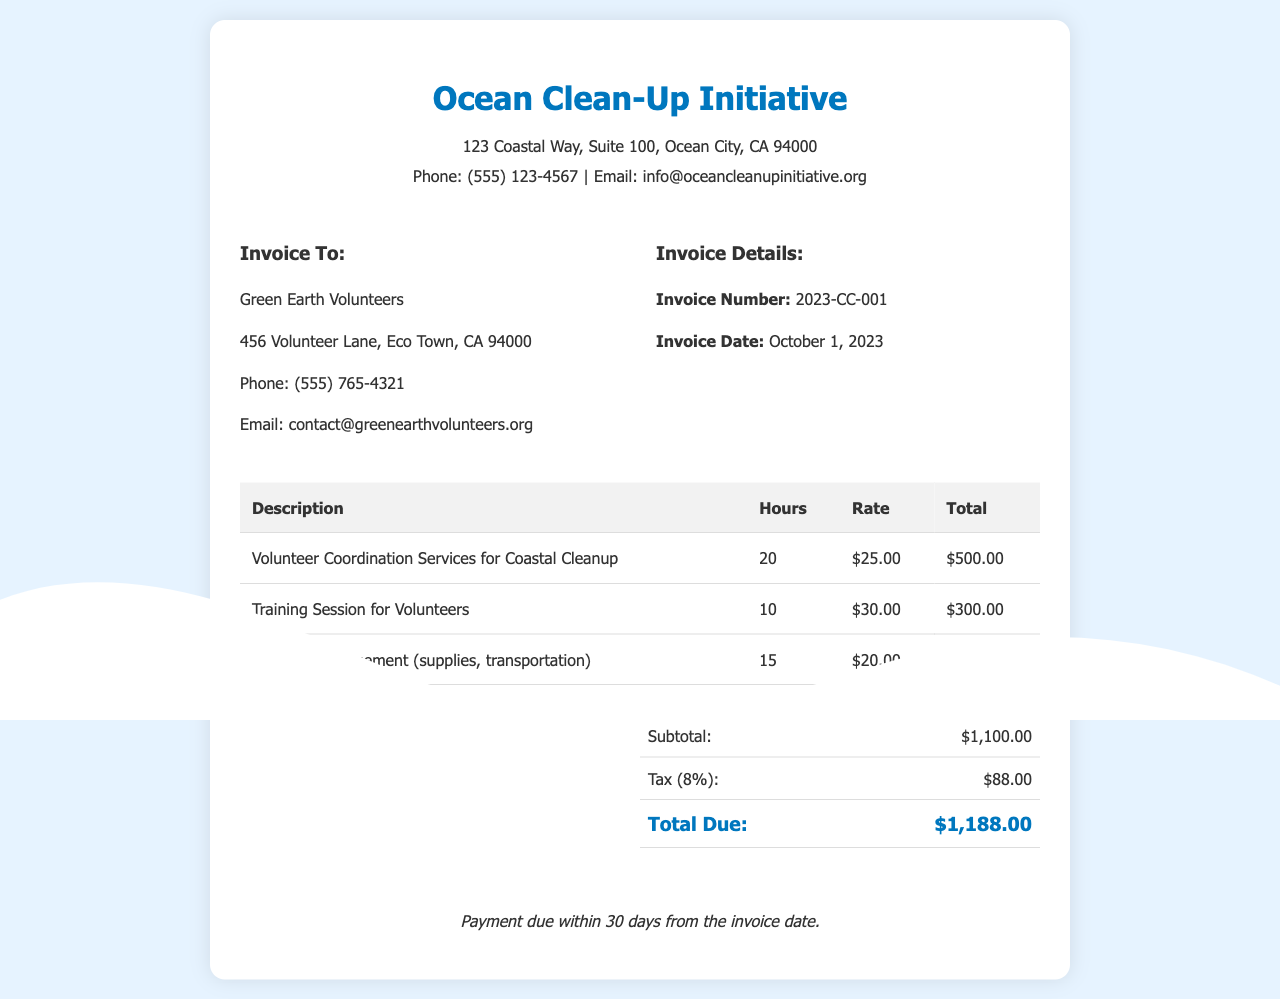What is the invoice number? The invoice number is identified in the invoice details section, which is 2023-CC-001.
Answer: 2023-CC-001 What is the total amount due? The total due is calculated at the bottom of the summary table, which is $1,188.00.
Answer: $1,188.00 Who is the recipient of the invoice? The recipient is listed under the 'Invoice To:' section, which is Green Earth Volunteers.
Answer: Green Earth Volunteers How many hours were worked for volunteer coordination services? The hours for volunteer coordination services are listed as 20 in the table under the relevant description.
Answer: 20 What date was the invoice issued? The invoice date is stated in the invoice details section, which is October 1, 2023.
Answer: October 1, 2023 What is the tax rate applied to the subtotal? The tax rate is mentioned in the summary, specifically noted as 8%.
Answer: 8% How many hours were allocated for the training session? The hours for the training session can be found in the table and are listed as 10.
Answer: 10 What type of services are provided by the invoice? The invoice provides coordination services for a coastal cleanup, training sessions, and logistics management.
Answer: Volunteer Coordination Services for Coastal Cleanup, Training Session for Volunteers, Logistics Management 